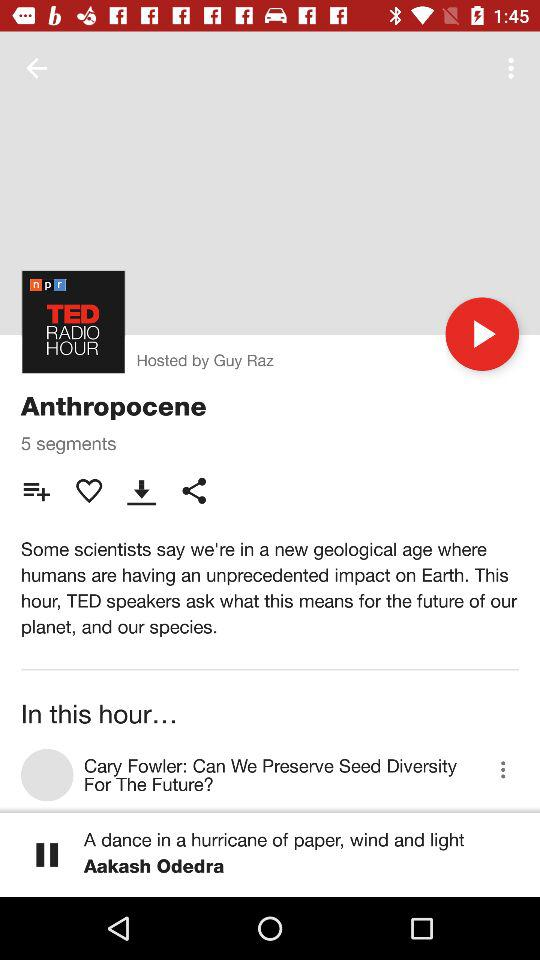Who has hosted the TED show? The TED show has been hosted by Guy Raz. 